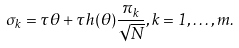Convert formula to latex. <formula><loc_0><loc_0><loc_500><loc_500>\sigma _ { k } = \tau \theta + \tau h ( \theta ) \frac { \pi _ { k } } { \sqrt { N } } , k = 1 , \dots , m .</formula> 